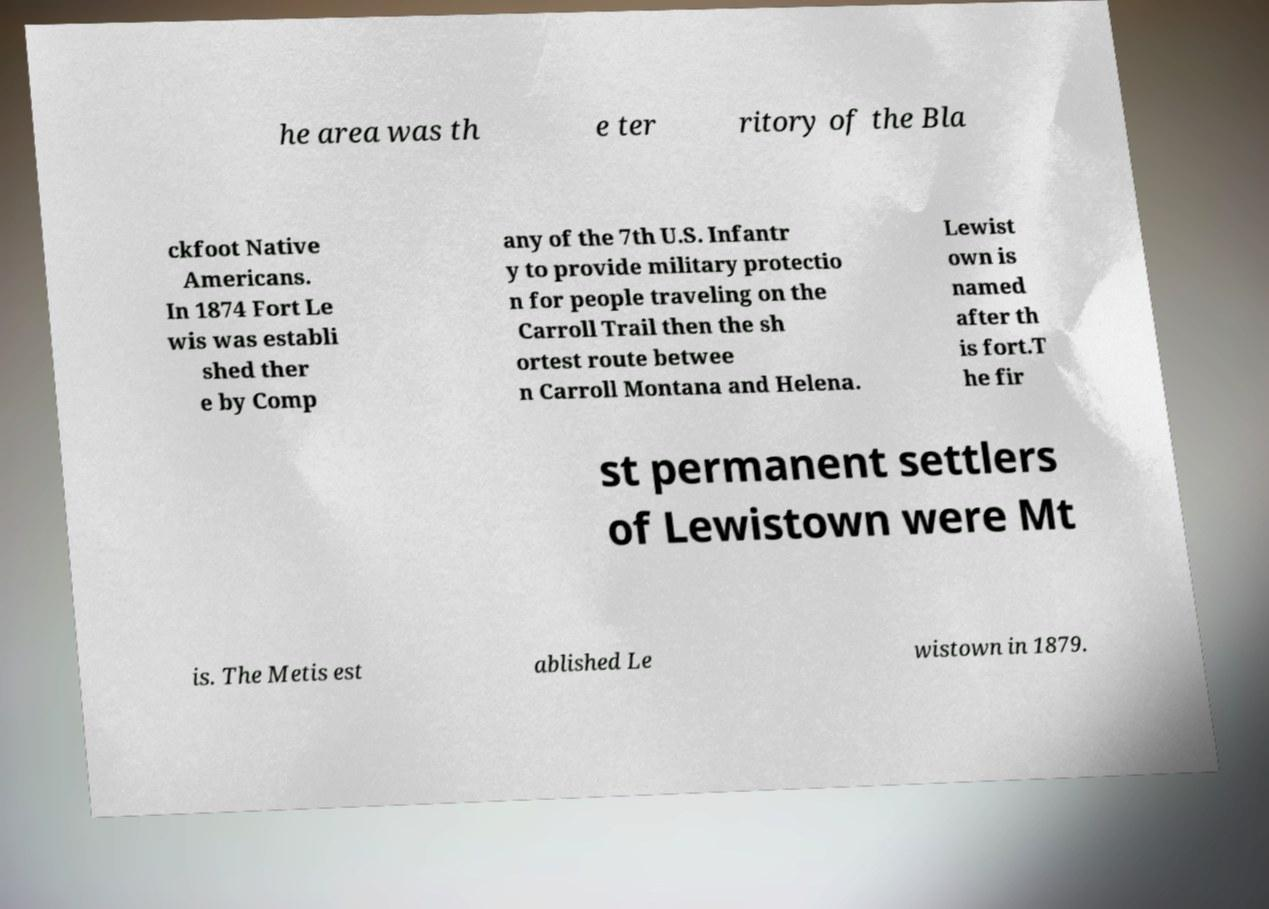I need the written content from this picture converted into text. Can you do that? he area was th e ter ritory of the Bla ckfoot Native Americans. In 1874 Fort Le wis was establi shed ther e by Comp any of the 7th U.S. Infantr y to provide military protectio n for people traveling on the Carroll Trail then the sh ortest route betwee n Carroll Montana and Helena. Lewist own is named after th is fort.T he fir st permanent settlers of Lewistown were Mt is. The Metis est ablished Le wistown in 1879. 